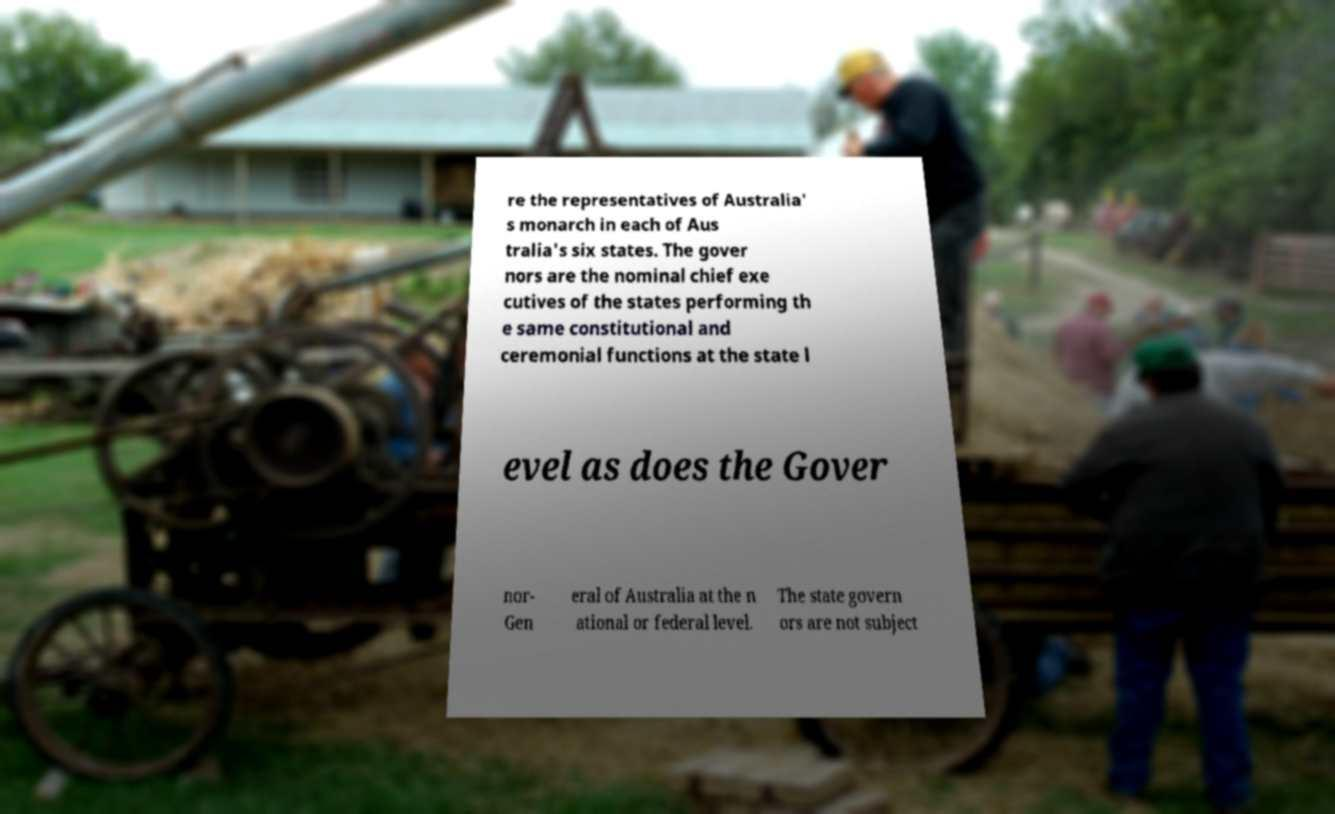Could you assist in decoding the text presented in this image and type it out clearly? re the representatives of Australia' s monarch in each of Aus tralia's six states. The gover nors are the nominal chief exe cutives of the states performing th e same constitutional and ceremonial functions at the state l evel as does the Gover nor- Gen eral of Australia at the n ational or federal level. The state govern ors are not subject 